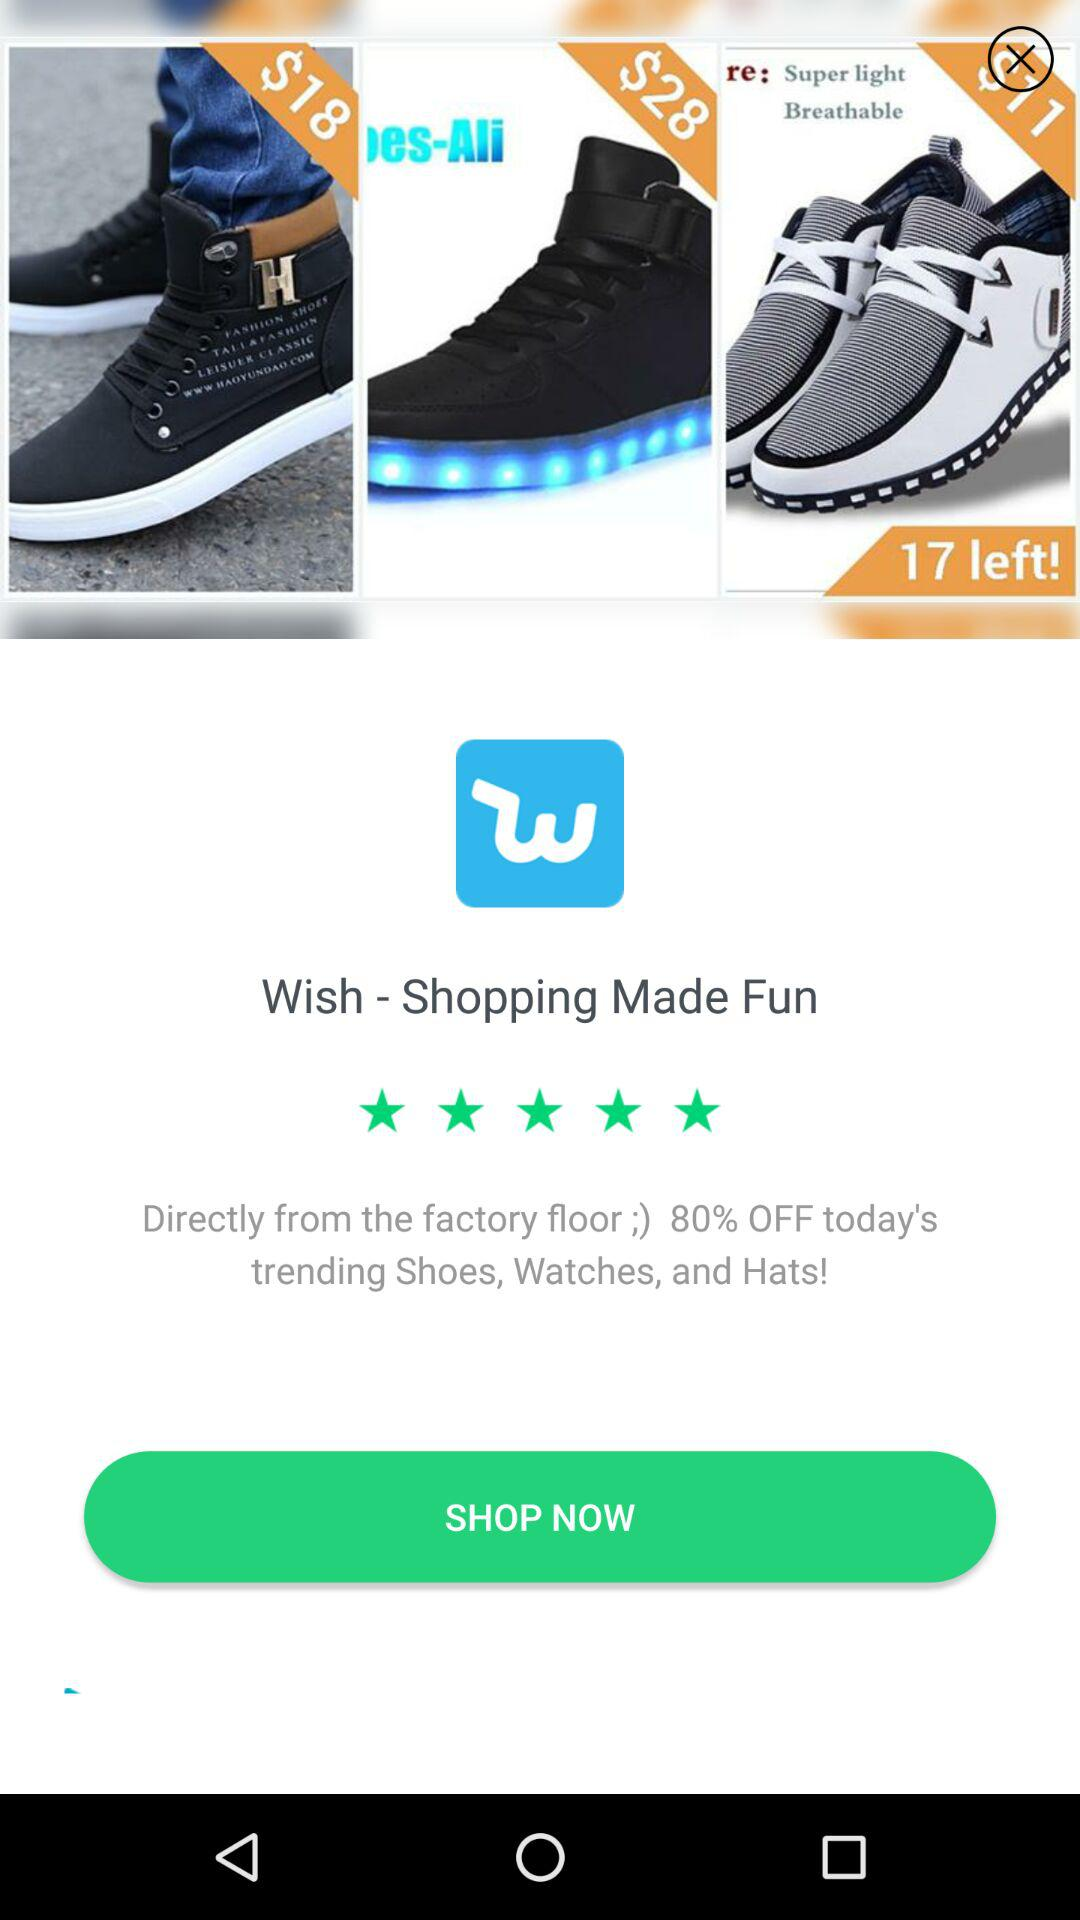How much more does the pair of shoes with blue lights cost than the pair of shoes with a white sole?
Answer the question using a single word or phrase. $10 